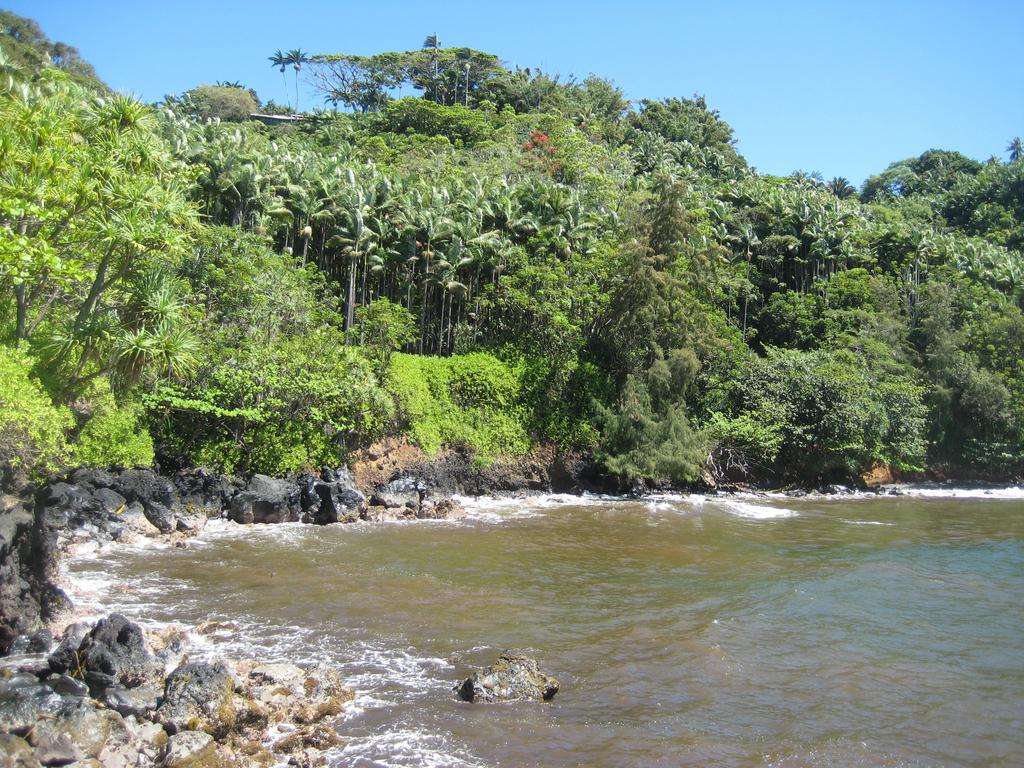What is the primary element visible in the image? There is water in the image. What other objects or features can be seen in the image? There are rocks and trees in the image. What is visible in the sky? There are clouds visible in the sky. Can you tell me how many hooks are hanging from the trees in the image? There are no hooks present in the image; it features water, rocks, trees, and clouds. Who is the expert in the image? There is no expert present in the image; it is a natural scene with water, rocks, trees, and clouds. 